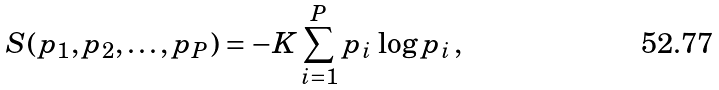Convert formula to latex. <formula><loc_0><loc_0><loc_500><loc_500>S ( p _ { 1 } , p _ { 2 } , \dots , p _ { P } ) = - K \sum _ { i = 1 } ^ { P } p _ { i } \, \log p _ { i } \, ,</formula> 